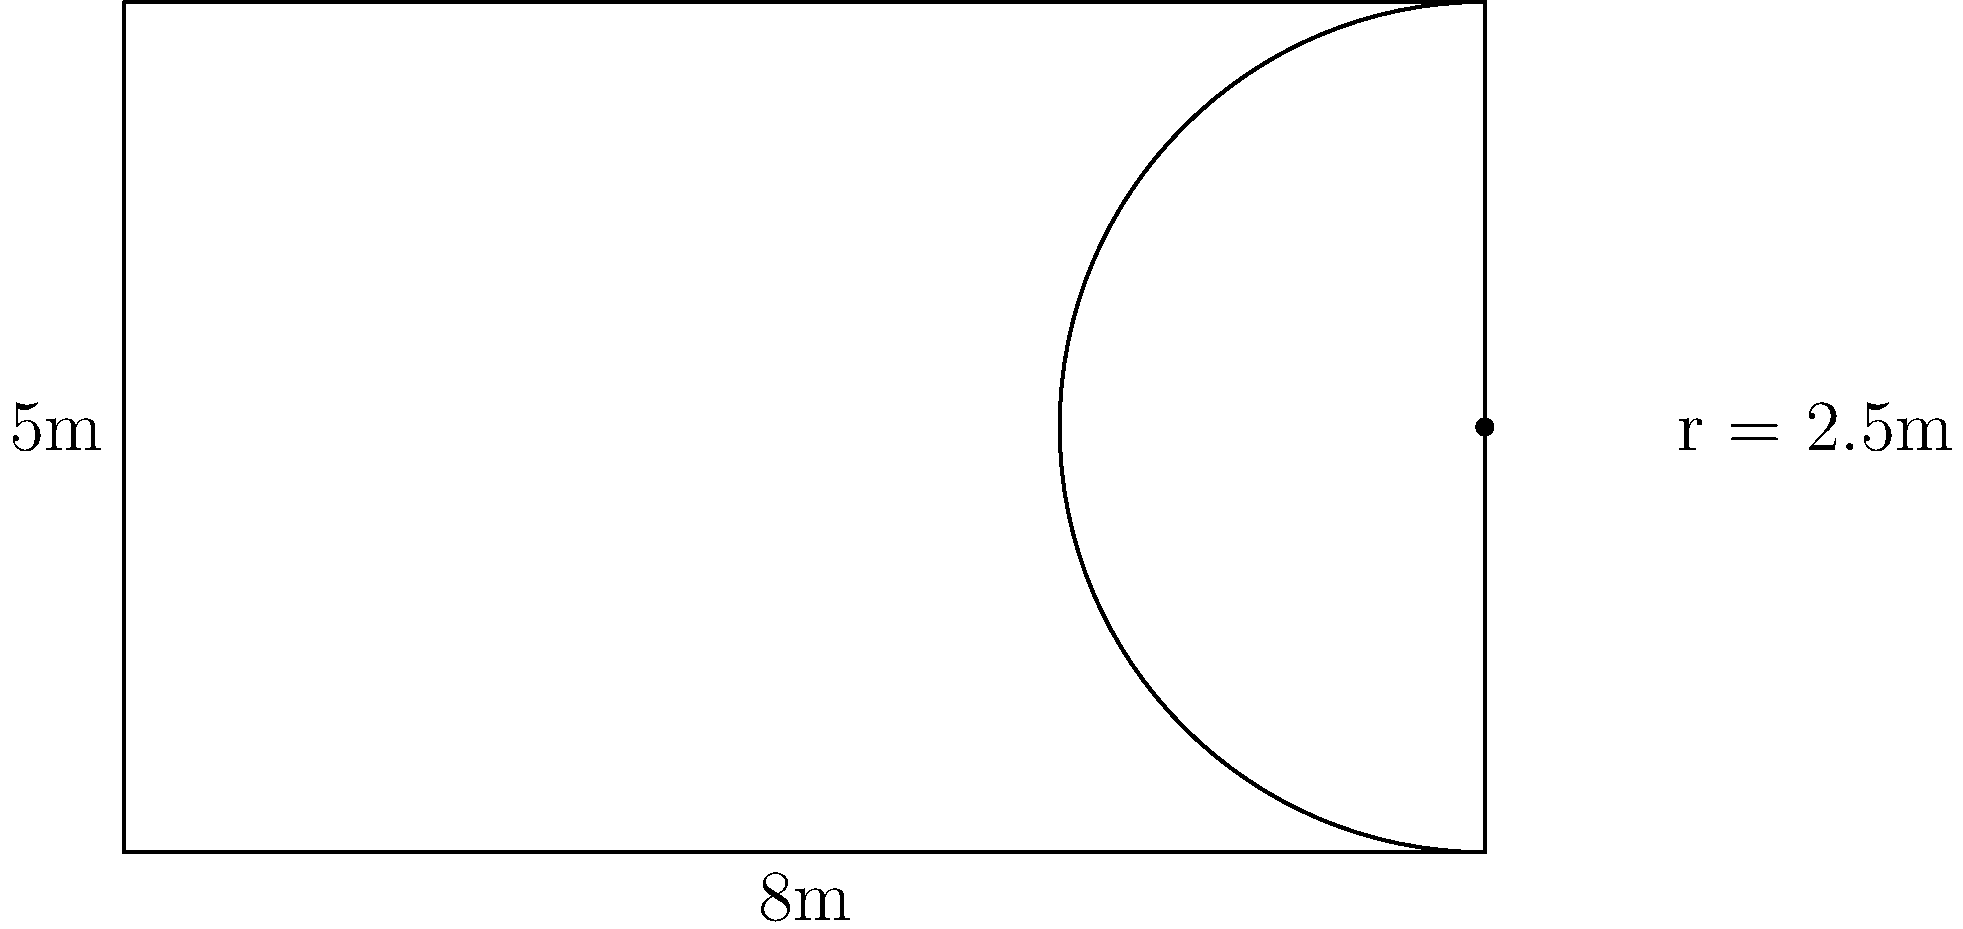As part of a youth empowerment initiative in Boke, you're designing an outdoor playground for a new youth center. The playground has a rectangular area with a semicircular extension on one side, as shown in the diagram. The rectangle measures 8m by 5m, and the radius of the semicircle is 2.5m. What is the total perimeter of the playground? To find the total perimeter, we need to calculate the length of the rectangular part and add it to the length of the curved part of the semicircle.

1. Calculate the perimeter of the rectangle without the side touching the semicircle:
   $$ 8m + 5m + 5m = 18m $$

2. Calculate the length of the curved part of the semicircle:
   The formula for the circumference of a circle is $2\pi r$
   Half of this gives us the semicircle: $\pi r$
   $$ \pi \times 2.5m = 7.85m \text{ (rounded to 2 decimal places)} $$

3. Add these lengths together:
   $$ 18m + 7.85m = 25.85m $$

Therefore, the total perimeter of the playground is approximately 25.85 meters.
Answer: 25.85m 